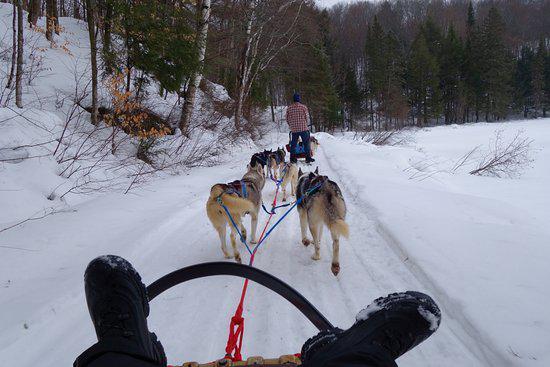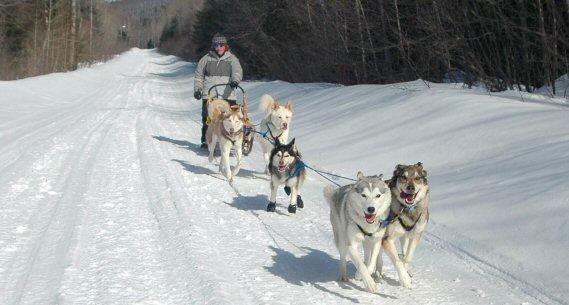The first image is the image on the left, the second image is the image on the right. For the images displayed, is the sentence "One image shows dogs that are part of a sled racing team and the other shows only the sled." factually correct? Answer yes or no. No. The first image is the image on the left, the second image is the image on the right. Evaluate the accuracy of this statement regarding the images: "One image shows an empty, unhitched, leftward-facing sled in the foreground, and the other image includes sled dogs in the foreground.". Is it true? Answer yes or no. No. 